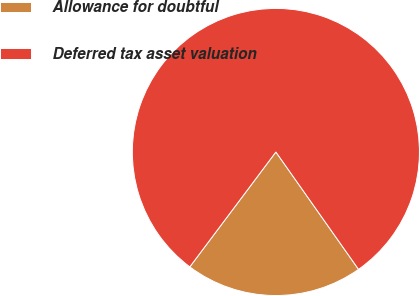<chart> <loc_0><loc_0><loc_500><loc_500><pie_chart><fcel>Allowance for doubtful<fcel>Deferred tax asset valuation<nl><fcel>20.0%<fcel>80.0%<nl></chart> 